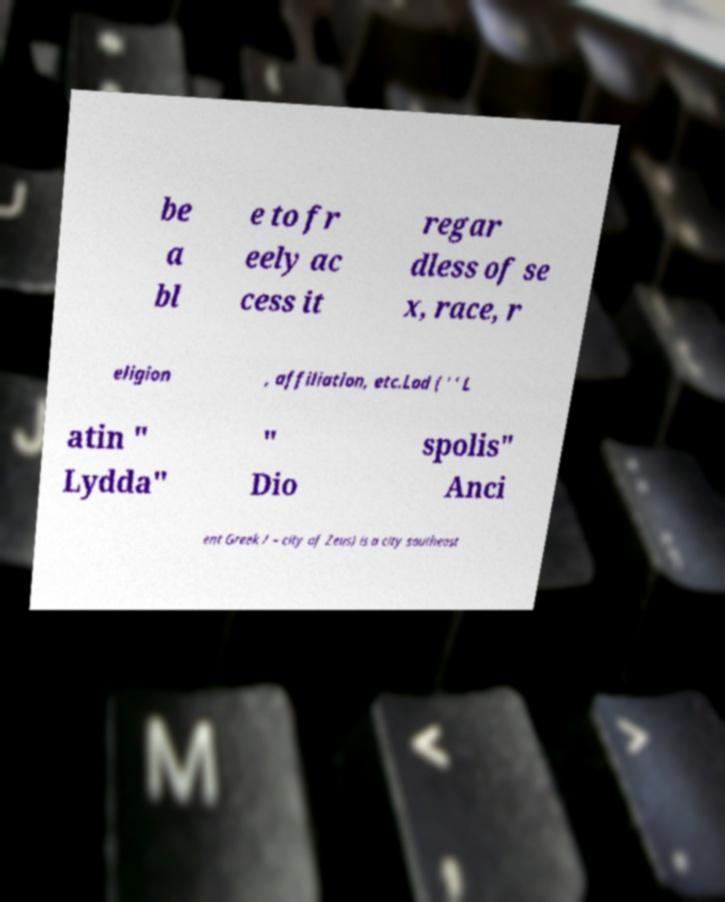Please identify and transcribe the text found in this image. be a bl e to fr eely ac cess it regar dless of se x, race, r eligion , affiliation, etc.Lod ( ' ' L atin " Lydda" " Dio spolis" Anci ent Greek / – city of Zeus) is a city southeast 